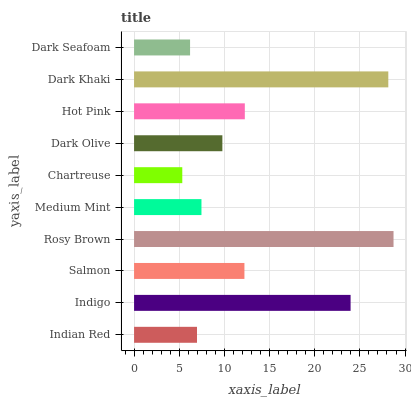Is Chartreuse the minimum?
Answer yes or no. Yes. Is Rosy Brown the maximum?
Answer yes or no. Yes. Is Indigo the minimum?
Answer yes or no. No. Is Indigo the maximum?
Answer yes or no. No. Is Indigo greater than Indian Red?
Answer yes or no. Yes. Is Indian Red less than Indigo?
Answer yes or no. Yes. Is Indian Red greater than Indigo?
Answer yes or no. No. Is Indigo less than Indian Red?
Answer yes or no. No. Is Salmon the high median?
Answer yes or no. Yes. Is Dark Olive the low median?
Answer yes or no. Yes. Is Chartreuse the high median?
Answer yes or no. No. Is Chartreuse the low median?
Answer yes or no. No. 